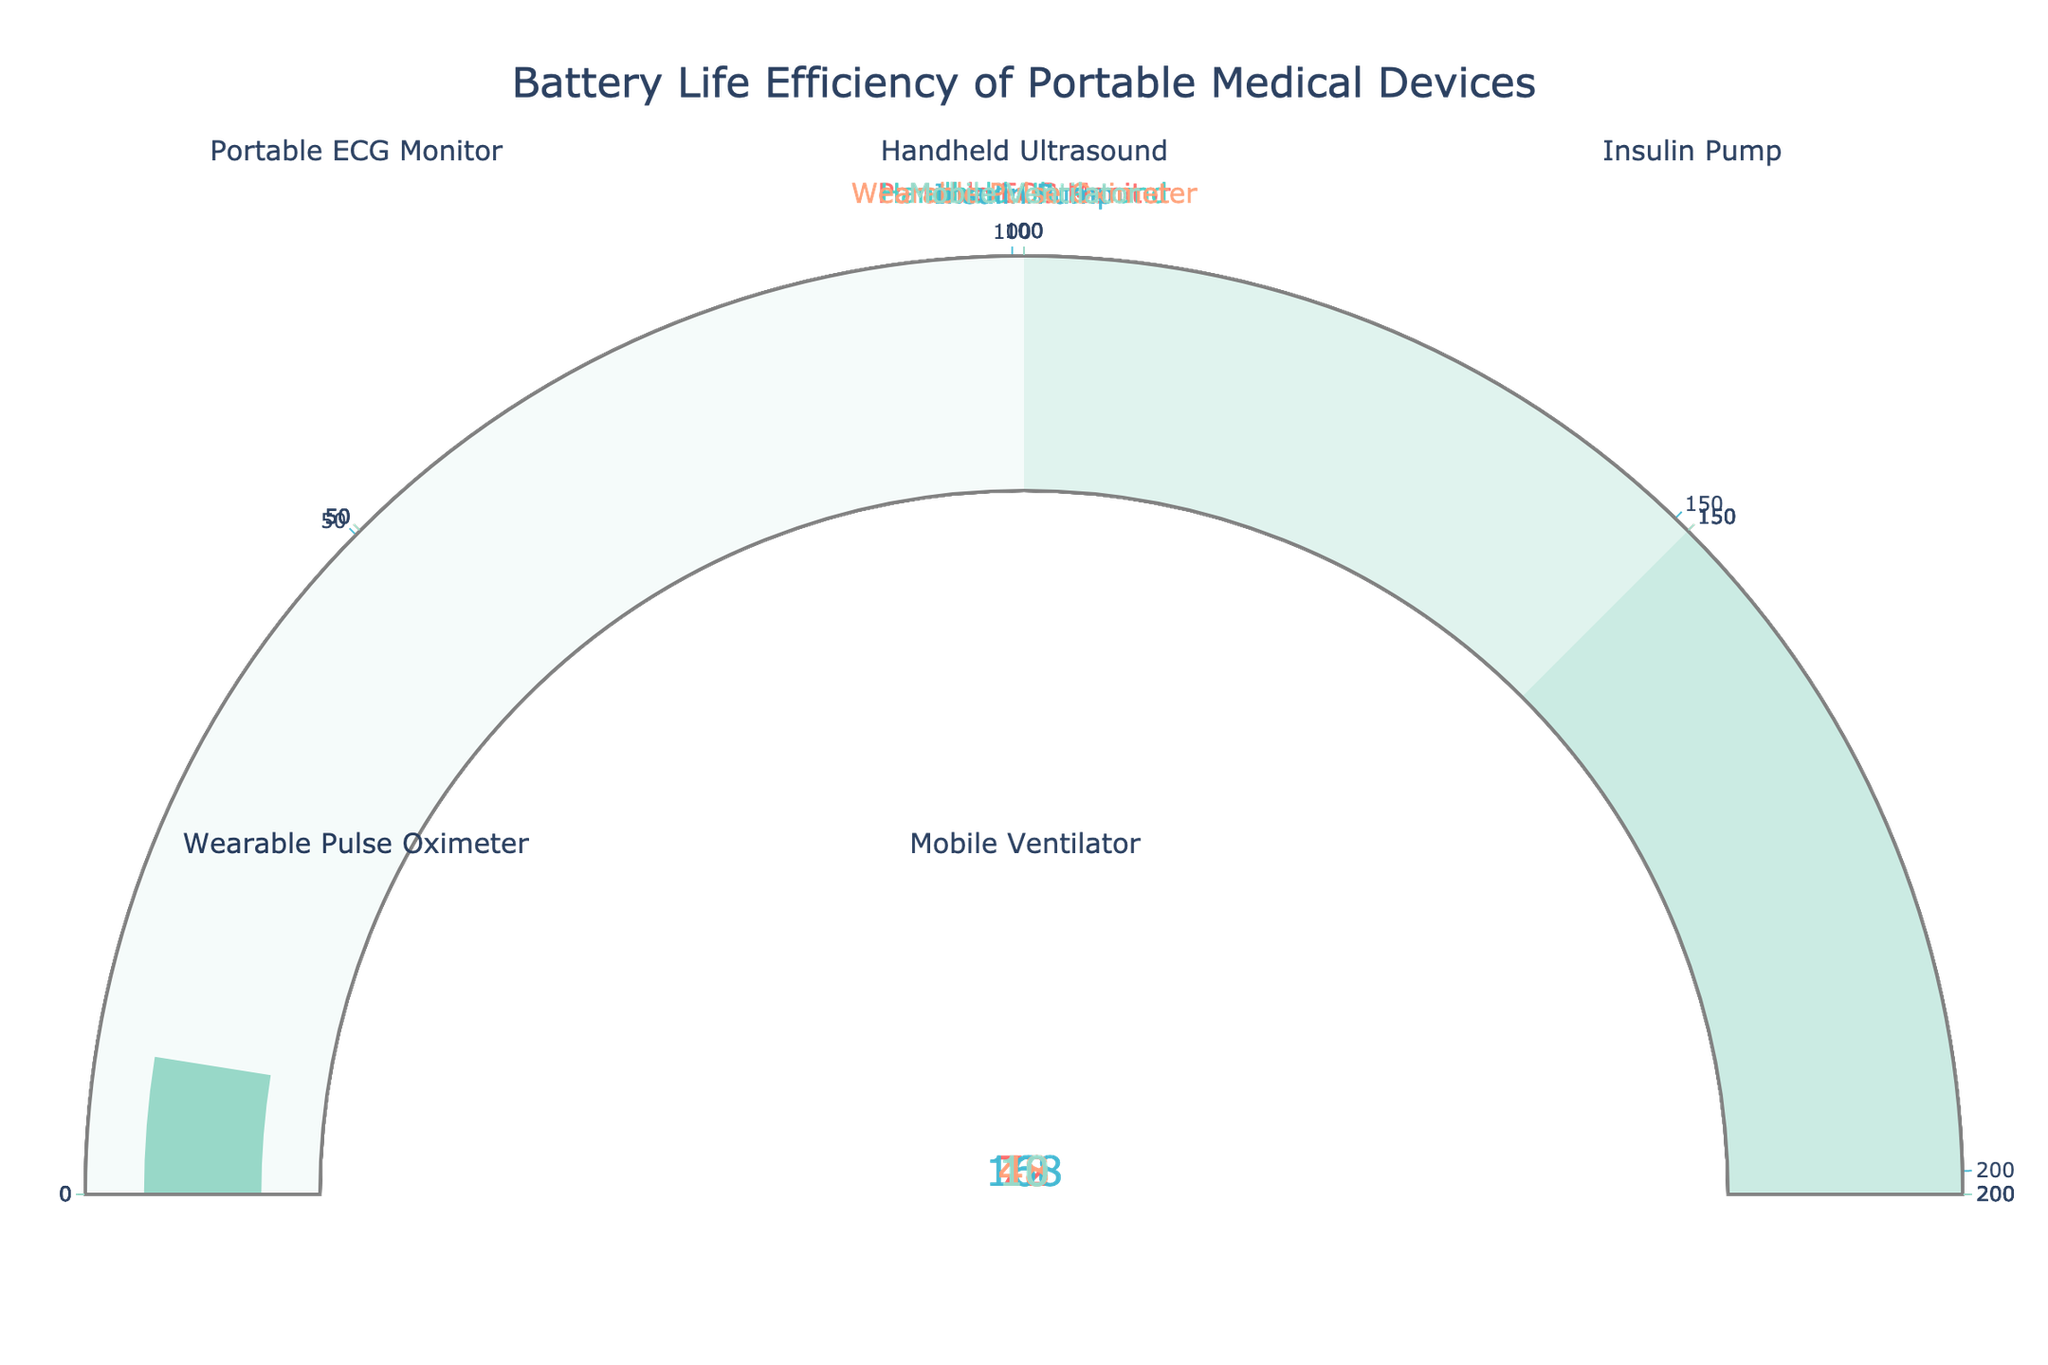What's the highest battery life among the devices? The handset with the highest battery life is determined by comparing all the values in the gauges. The Insulin Pump shows the highest battery life at 168 hours.
Answer: 168 hours What device has the shortest battery life? By reviewing each gauge, the Handheld Ultrasound has the shortest battery life, displaying 6 hours on the gauge.
Answer: Handheld Ultrasound What's the total battery life for all devices combined? Adding all the battery life values together: 72 (ECG Monitor) + 6 (Ultrasound) + 168 (Insulin Pump) + 48 (Pulse Oximeter) + 10 (Ventilator) = 304 hours.
Answer: 304 hours How does the battery life of the Wearable Pulse Oximeter compare with the Portable ECG Monitor? Comparing the two gauges, the Wearable Pulse Oximeter shows a battery life of 48 hours, while the Portable ECG Monitor shows 72 hours. The ECG Monitor has a higher battery life.
Answer: ECG Monitor has higher battery life Which device would likely need recharging most frequently? The device with the lowest battery life will need recharging the most often. The Handheld Ultrasound has the shortest battery life at 6 hours.
Answer: Handheld Ultrasound What's the difference in battery life between the Mobile Ventilator and the Insulin Pump? Subtraction of the battery life of the Mobile Ventilator (10 hours) from the Insulin Pump (168 hours) results in a difference of 158 hours.
Answer: 158 hours How many devices have a battery life of more than 50 hours? Checking each gauge, the Portable ECG Monitor (72 hours) and the Insulin Pump (168 hours) both have more than 50 hours, so 2 devices meet this condition.
Answer: 2 devices What's the average battery life of the devices? Summing the battery lives (304 hours) and dividing by the number of devices (5): 304 / 5 = 60.8 hours.
Answer: 60.8 hours Which device has approximately triple the battery life of the Wearable Pulse Oximeter? The Wearable Pulse Oximeter has 48 hours of battery life; triple this is 144 hours. The Insulin Pump has 168 hours, which is closest to and greater than triple the Pulse Oximeter’s battery life, giving an approximate match.
Answer: Insulin Pump 